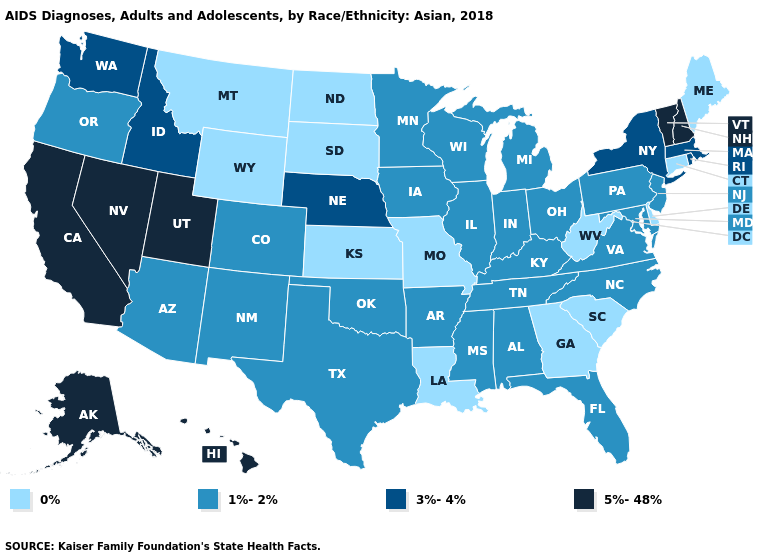Name the states that have a value in the range 1%-2%?
Answer briefly. Alabama, Arizona, Arkansas, Colorado, Florida, Illinois, Indiana, Iowa, Kentucky, Maryland, Michigan, Minnesota, Mississippi, New Jersey, New Mexico, North Carolina, Ohio, Oklahoma, Oregon, Pennsylvania, Tennessee, Texas, Virginia, Wisconsin. Does the map have missing data?
Quick response, please. No. What is the value of Massachusetts?
Short answer required. 3%-4%. What is the value of Connecticut?
Give a very brief answer. 0%. Does North Dakota have a lower value than Maine?
Be succinct. No. What is the value of Idaho?
Write a very short answer. 3%-4%. What is the value of Pennsylvania?
Write a very short answer. 1%-2%. What is the lowest value in the USA?
Be succinct. 0%. Name the states that have a value in the range 3%-4%?
Short answer required. Idaho, Massachusetts, Nebraska, New York, Rhode Island, Washington. Name the states that have a value in the range 0%?
Concise answer only. Connecticut, Delaware, Georgia, Kansas, Louisiana, Maine, Missouri, Montana, North Dakota, South Carolina, South Dakota, West Virginia, Wyoming. Among the states that border Iowa , does South Dakota have the lowest value?
Give a very brief answer. Yes. Name the states that have a value in the range 3%-4%?
Answer briefly. Idaho, Massachusetts, Nebraska, New York, Rhode Island, Washington. What is the highest value in the USA?
Short answer required. 5%-48%. Which states hav the highest value in the MidWest?
Keep it brief. Nebraska. Is the legend a continuous bar?
Be succinct. No. 